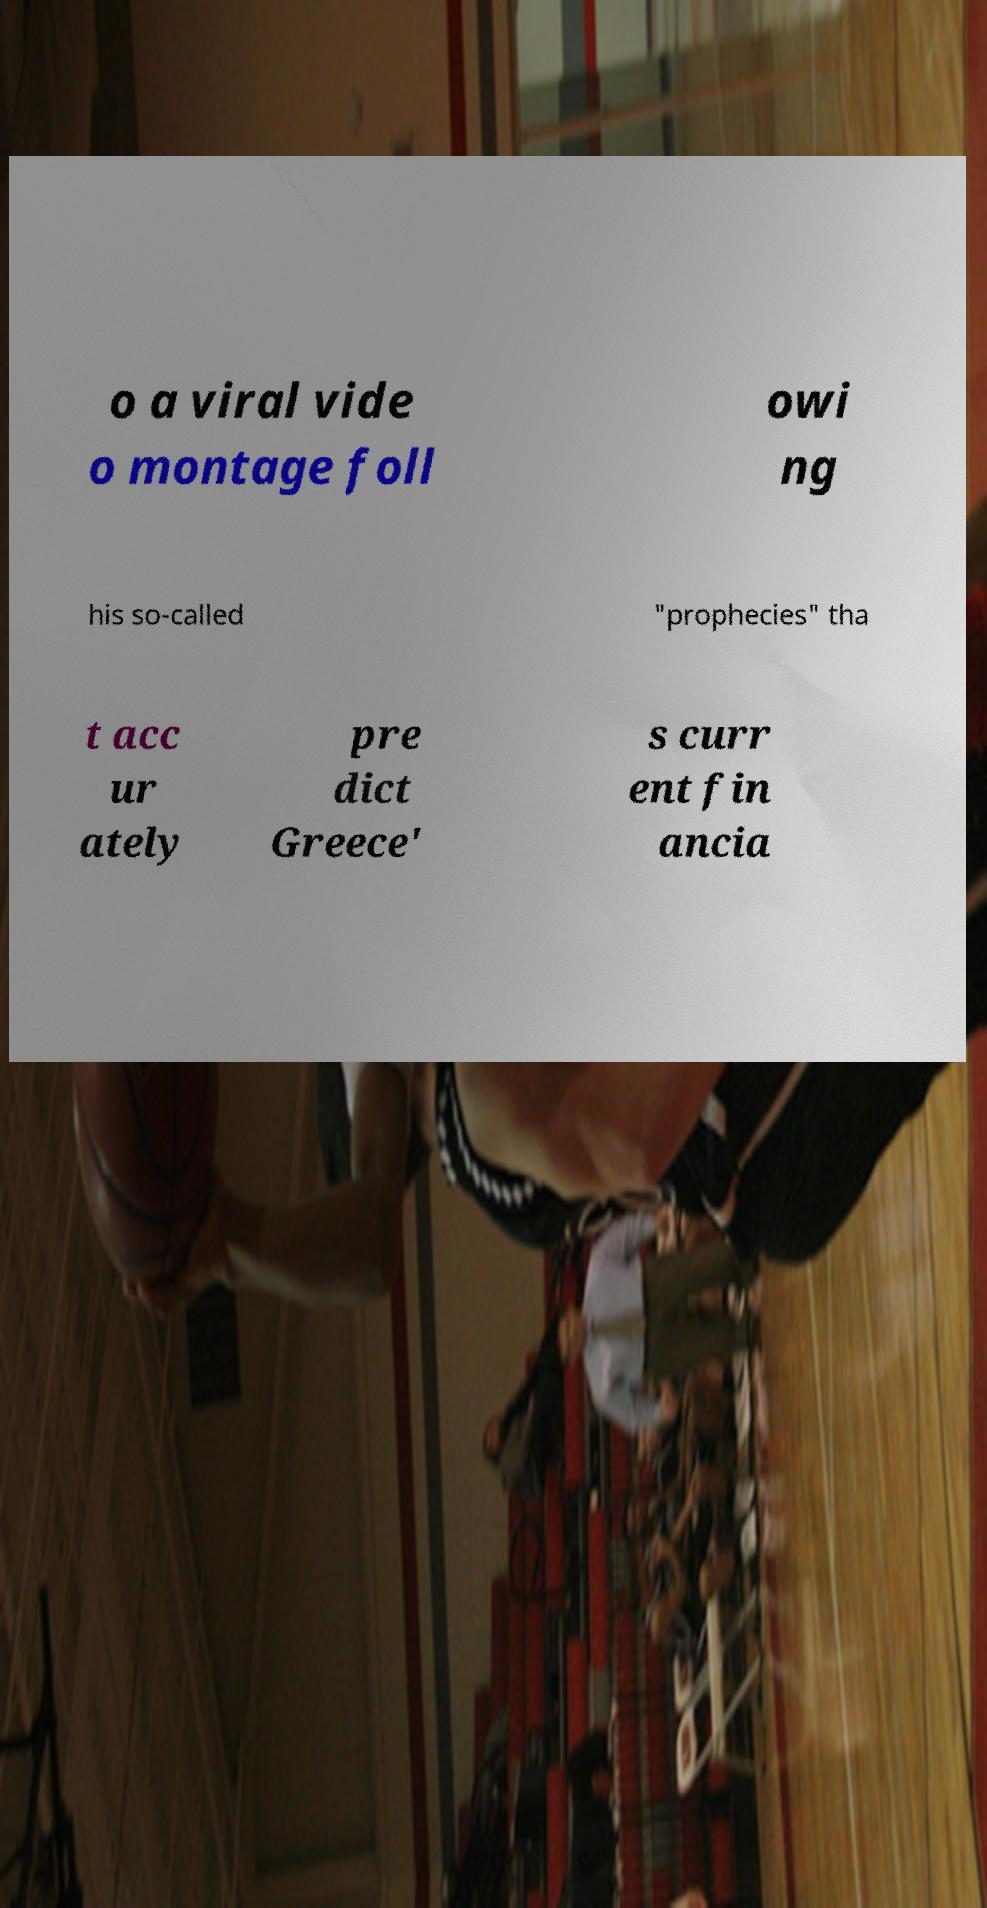There's text embedded in this image that I need extracted. Can you transcribe it verbatim? o a viral vide o montage foll owi ng his so-called "prophecies" tha t acc ur ately pre dict Greece' s curr ent fin ancia 